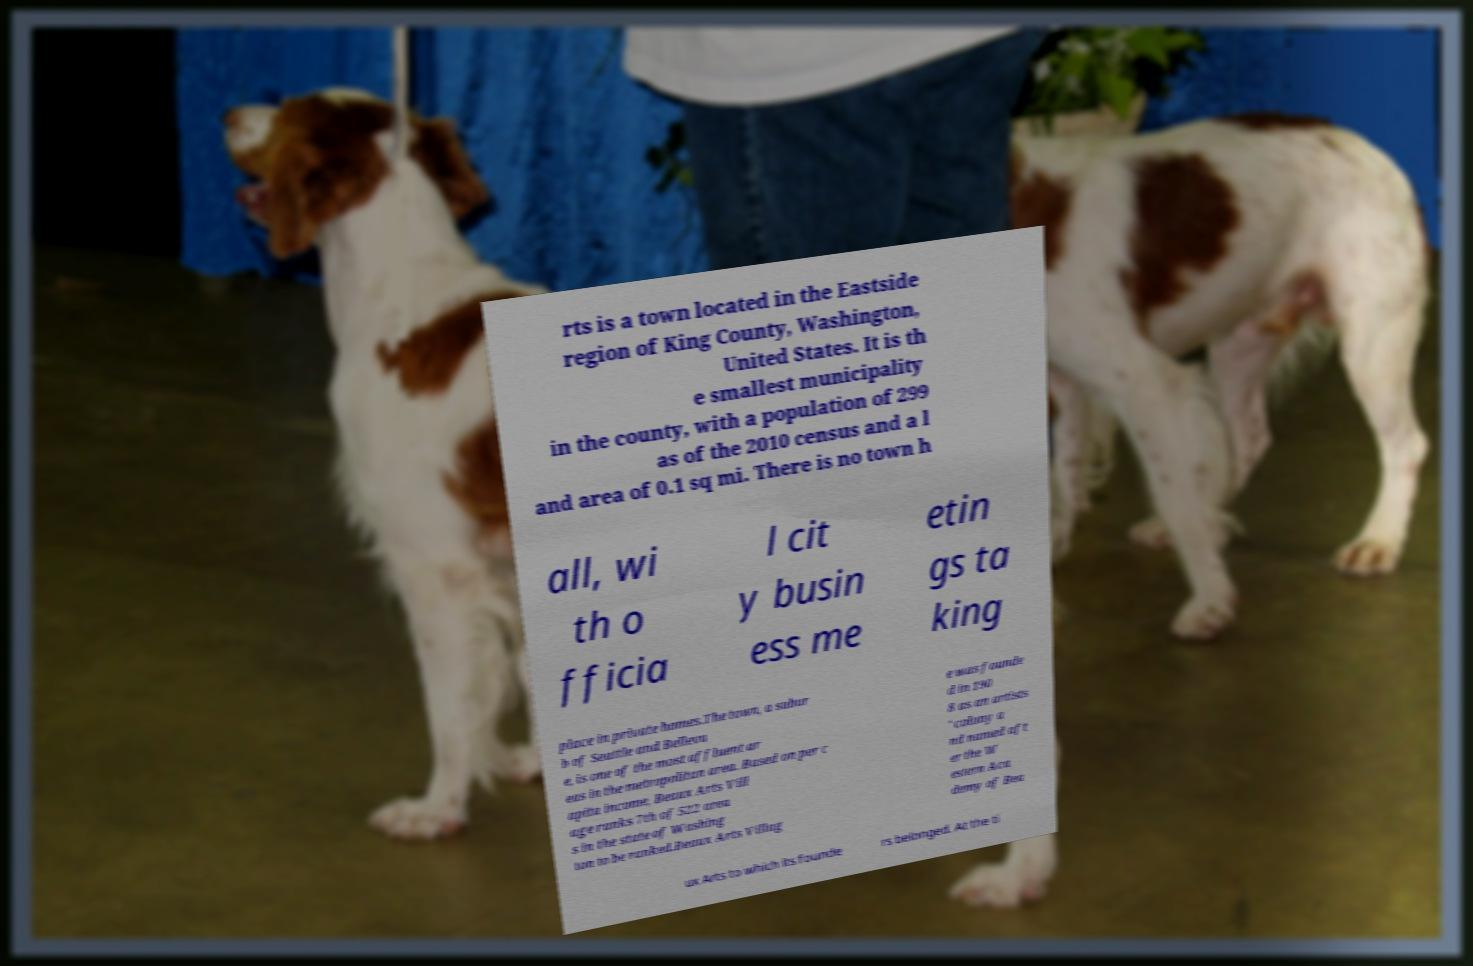Please identify and transcribe the text found in this image. rts is a town located in the Eastside region of King County, Washington, United States. It is th e smallest municipality in the county, with a population of 299 as of the 2010 census and a l and area of 0.1 sq mi. There is no town h all, wi th o fficia l cit y busin ess me etin gs ta king place in private homes.The town, a subur b of Seattle and Bellevu e, is one of the most affluent ar eas in the metropolitan area. Based on per c apita income, Beaux Arts Vill age ranks 7th of 522 area s in the state of Washing ton to be ranked.Beaux Arts Villag e was founde d in 190 8 as an artists ' colony a nd named aft er the W estern Aca demy of Bea ux Arts to which its founde rs belonged. At the ti 